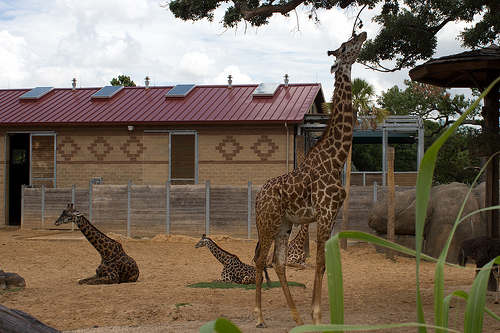Imagine a scenario where the giraffes are interacting with other animals in the sharegpt4v/same enclosure. Imagine the sharegpt4v/same enclosure, but now it's bustling with the presence of other animals like zebras, gazelles, and ostriches. The giraffes, towering above the rest, would be calmly browsing on the higher bushes and leaves while the zebras and gazelles graze on the lower grasses. Ostriches, with their curious nature, might approach the giraffes, and the entire scene would be a vibrant display of wildlife interaction within a shared habitat, showcasing the harmony and diversity of savannah life. 